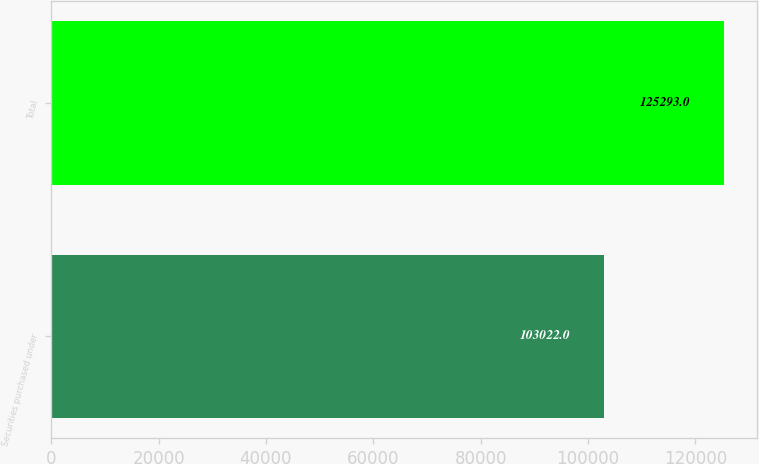Convert chart to OTSL. <chart><loc_0><loc_0><loc_500><loc_500><bar_chart><fcel>Securities purchased under<fcel>Total<nl><fcel>103022<fcel>125293<nl></chart> 